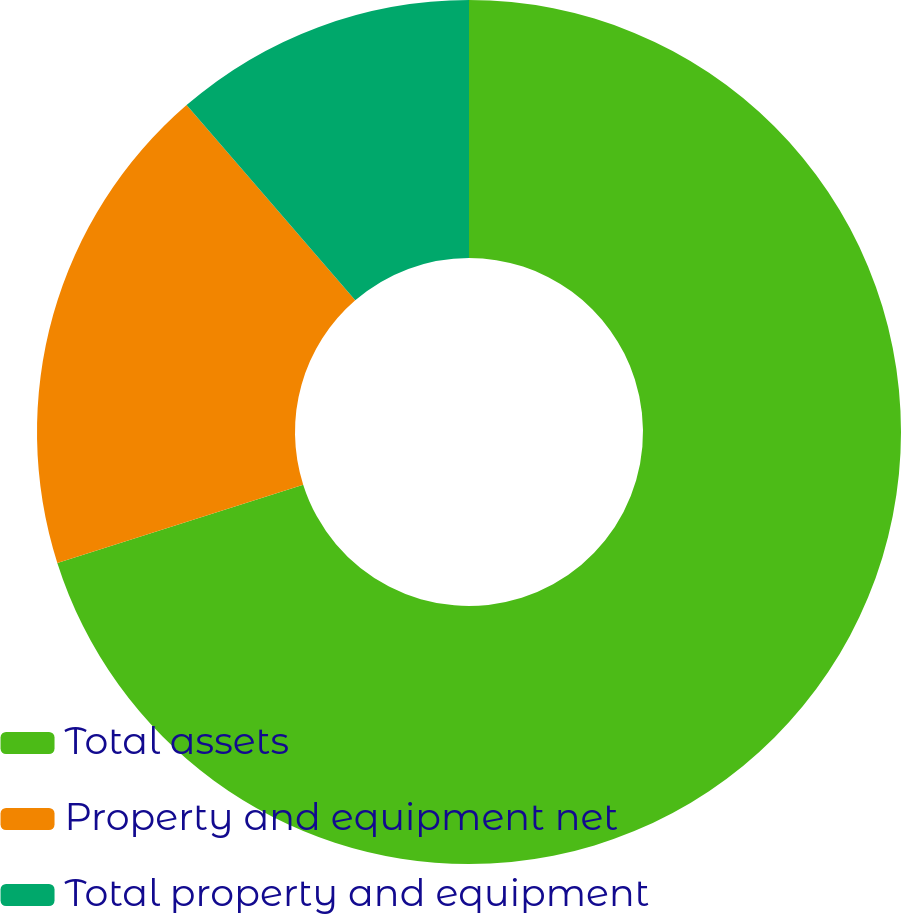Convert chart to OTSL. <chart><loc_0><loc_0><loc_500><loc_500><pie_chart><fcel>Total assets<fcel>Property and equipment net<fcel>Total property and equipment<nl><fcel>70.1%<fcel>18.56%<fcel>11.34%<nl></chart> 